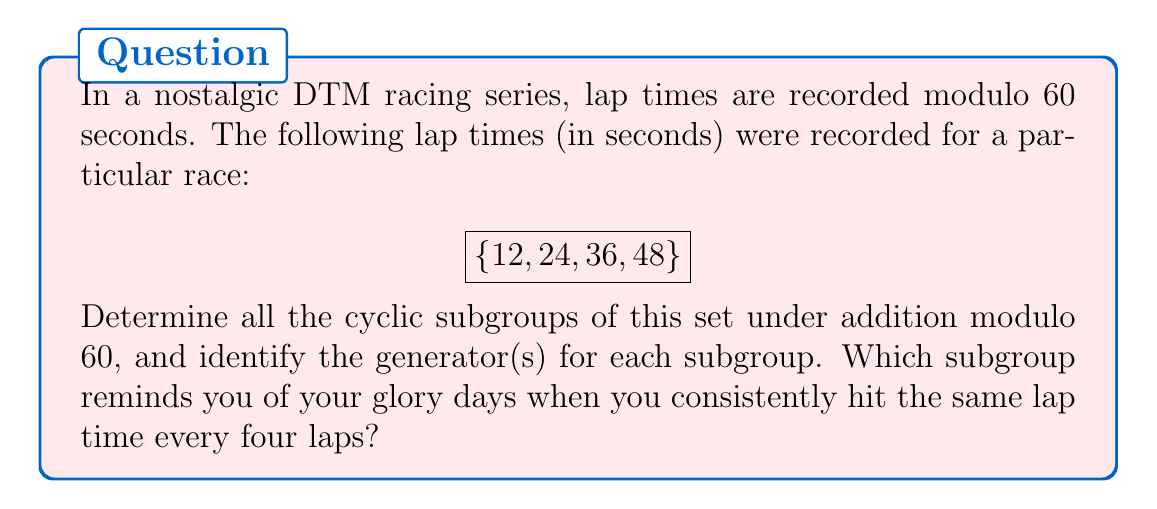Solve this math problem. Let's approach this step-by-step:

1) First, we need to understand that this set forms a group under addition modulo 60. Let's call this group G.

2) To find cyclic subgroups, we need to generate subgroups from each element:

   a) $\langle 12 \rangle = \{12, 24, 36, 48, 0\}$ (0 is included as $12 \cdot 5 \equiv 0 \pmod{60}$)
   b) $\langle 24 \rangle = \{24, 48, 12, 36, 0\}$
   c) $\langle 36 \rangle = \{36, 12, 48, 24, 0\}$
   d) $\langle 48 \rangle = \{48, 36, 24, 12, 0\}$

3) We can see that all these generated subgroups are actually the same, containing all elements of the original set plus 0.

4) Therefore, there are only two distinct cyclic subgroups:
   - The trivial subgroup: $\{0\}$
   - The entire group: $\{0, 12, 24, 36, 48\}$

5) The generators for the entire group are 12, 24, 36, and 48, as each of these generates the whole group.

6) The subgroup that repeats every four laps is the entire group, as it takes four additions of 12 (or any other element) to return to the starting point (48 + 12 ≡ 0 mod 60).
Answer: Two cyclic subgroups: $\{0\}$ and $\{0, 12, 24, 36, 48\}$. Generators of the non-trivial subgroup: 12, 24, 36, 48. 